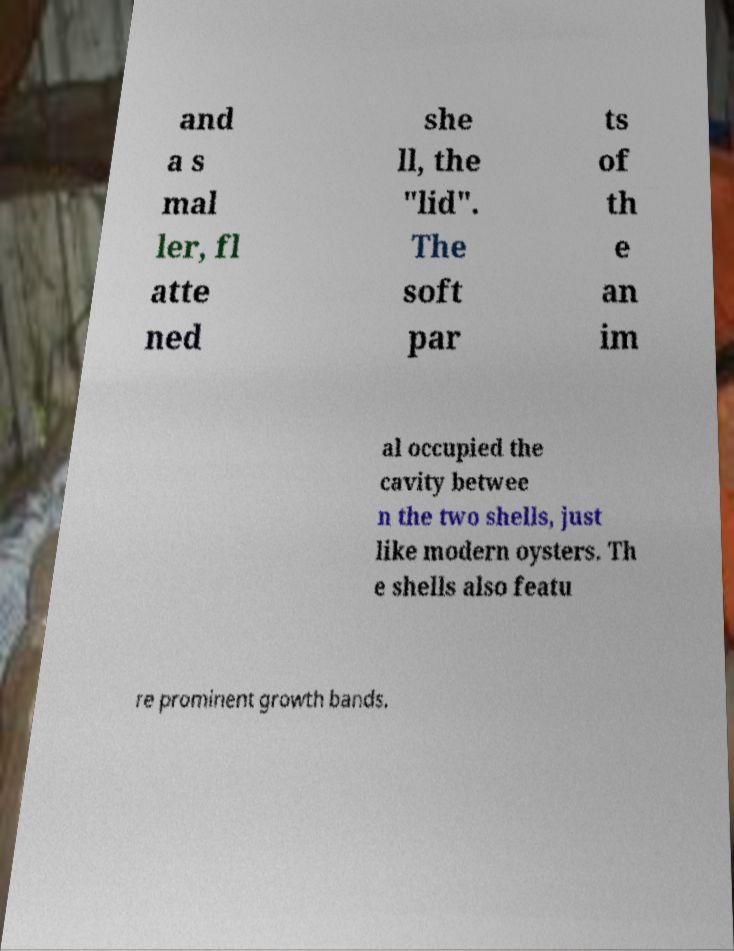Can you read and provide the text displayed in the image?This photo seems to have some interesting text. Can you extract and type it out for me? and a s mal ler, fl atte ned she ll, the "lid". The soft par ts of th e an im al occupied the cavity betwee n the two shells, just like modern oysters. Th e shells also featu re prominent growth bands. 